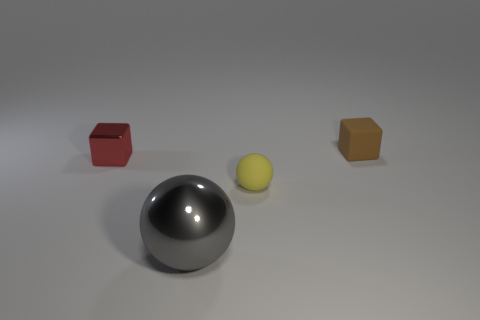Add 4 brown rubber cubes. How many objects exist? 8 Subtract 1 cubes. How many cubes are left? 1 Subtract all purple spheres. Subtract all red blocks. How many spheres are left? 2 Subtract all blue cubes. How many gray spheres are left? 1 Subtract all brown blocks. Subtract all metallic cubes. How many objects are left? 2 Add 1 tiny brown rubber things. How many tiny brown rubber things are left? 2 Add 1 small green matte spheres. How many small green matte spheres exist? 1 Subtract all red blocks. How many blocks are left? 1 Subtract 1 yellow balls. How many objects are left? 3 